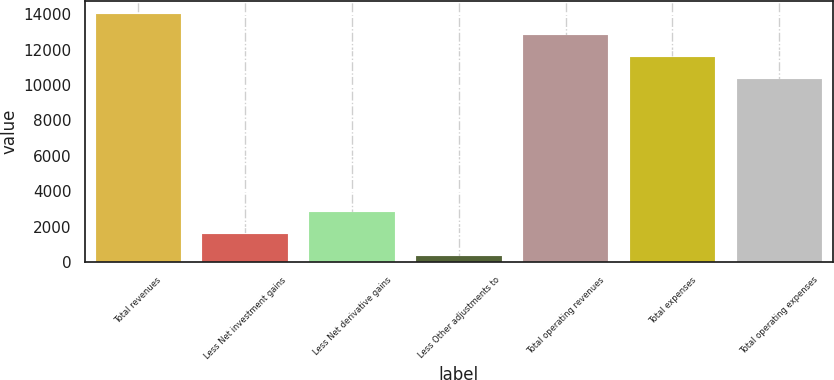Convert chart. <chart><loc_0><loc_0><loc_500><loc_500><bar_chart><fcel>Total revenues<fcel>Less Net investment gains<fcel>Less Net derivative gains<fcel>Less Other adjustments to<fcel>Total operating revenues<fcel>Total expenses<fcel>Total operating expenses<nl><fcel>14021.6<fcel>1592.2<fcel>2813.4<fcel>371<fcel>12800.4<fcel>11579.2<fcel>10358<nl></chart> 